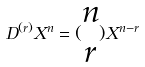Convert formula to latex. <formula><loc_0><loc_0><loc_500><loc_500>D ^ { ( r ) } X ^ { n } = ( \begin{matrix} n \\ r \end{matrix} ) X ^ { n - r }</formula> 